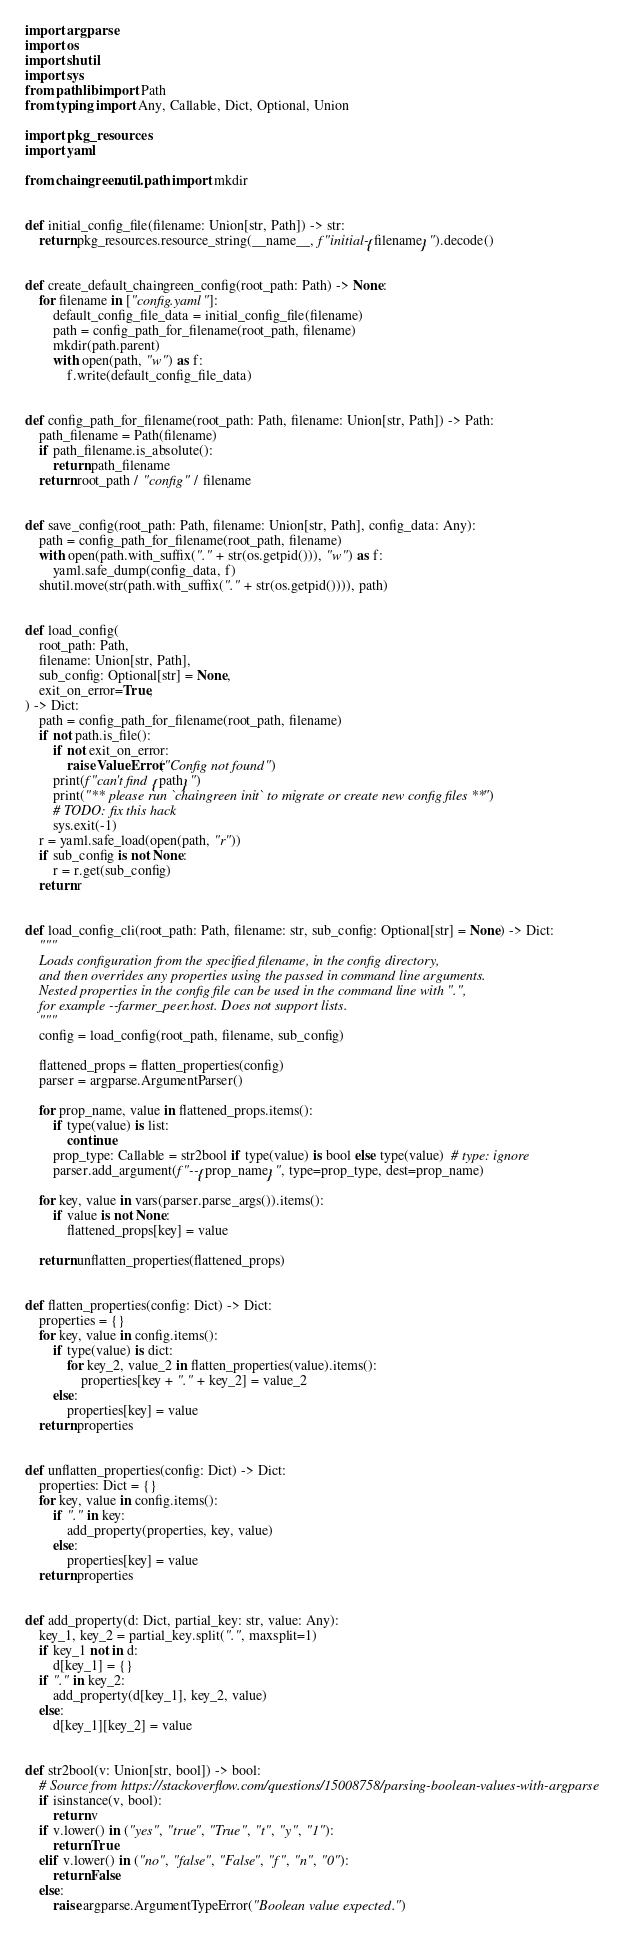Convert code to text. <code><loc_0><loc_0><loc_500><loc_500><_Python_>import argparse
import os
import shutil
import sys
from pathlib import Path
from typing import Any, Callable, Dict, Optional, Union

import pkg_resources
import yaml

from chaingreen.util.path import mkdir


def initial_config_file(filename: Union[str, Path]) -> str:
    return pkg_resources.resource_string(__name__, f"initial-{filename}").decode()


def create_default_chaingreen_config(root_path: Path) -> None:
    for filename in ["config.yaml"]:
        default_config_file_data = initial_config_file(filename)
        path = config_path_for_filename(root_path, filename)
        mkdir(path.parent)
        with open(path, "w") as f:
            f.write(default_config_file_data)


def config_path_for_filename(root_path: Path, filename: Union[str, Path]) -> Path:
    path_filename = Path(filename)
    if path_filename.is_absolute():
        return path_filename
    return root_path / "config" / filename


def save_config(root_path: Path, filename: Union[str, Path], config_data: Any):
    path = config_path_for_filename(root_path, filename)
    with open(path.with_suffix("." + str(os.getpid())), "w") as f:
        yaml.safe_dump(config_data, f)
    shutil.move(str(path.with_suffix("." + str(os.getpid()))), path)


def load_config(
    root_path: Path,
    filename: Union[str, Path],
    sub_config: Optional[str] = None,
    exit_on_error=True,
) -> Dict:
    path = config_path_for_filename(root_path, filename)
    if not path.is_file():
        if not exit_on_error:
            raise ValueError("Config not found")
        print(f"can't find {path}")
        print("** please run `chaingreen init` to migrate or create new config files **")
        # TODO: fix this hack
        sys.exit(-1)
    r = yaml.safe_load(open(path, "r"))
    if sub_config is not None:
        r = r.get(sub_config)
    return r


def load_config_cli(root_path: Path, filename: str, sub_config: Optional[str] = None) -> Dict:
    """
    Loads configuration from the specified filename, in the config directory,
    and then overrides any properties using the passed in command line arguments.
    Nested properties in the config file can be used in the command line with ".",
    for example --farmer_peer.host. Does not support lists.
    """
    config = load_config(root_path, filename, sub_config)

    flattened_props = flatten_properties(config)
    parser = argparse.ArgumentParser()

    for prop_name, value in flattened_props.items():
        if type(value) is list:
            continue
        prop_type: Callable = str2bool if type(value) is bool else type(value)  # type: ignore
        parser.add_argument(f"--{prop_name}", type=prop_type, dest=prop_name)

    for key, value in vars(parser.parse_args()).items():
        if value is not None:
            flattened_props[key] = value

    return unflatten_properties(flattened_props)


def flatten_properties(config: Dict) -> Dict:
    properties = {}
    for key, value in config.items():
        if type(value) is dict:
            for key_2, value_2 in flatten_properties(value).items():
                properties[key + "." + key_2] = value_2
        else:
            properties[key] = value
    return properties


def unflatten_properties(config: Dict) -> Dict:
    properties: Dict = {}
    for key, value in config.items():
        if "." in key:
            add_property(properties, key, value)
        else:
            properties[key] = value
    return properties


def add_property(d: Dict, partial_key: str, value: Any):
    key_1, key_2 = partial_key.split(".", maxsplit=1)
    if key_1 not in d:
        d[key_1] = {}
    if "." in key_2:
        add_property(d[key_1], key_2, value)
    else:
        d[key_1][key_2] = value


def str2bool(v: Union[str, bool]) -> bool:
    # Source from https://stackoverflow.com/questions/15008758/parsing-boolean-values-with-argparse
    if isinstance(v, bool):
        return v
    if v.lower() in ("yes", "true", "True", "t", "y", "1"):
        return True
    elif v.lower() in ("no", "false", "False", "f", "n", "0"):
        return False
    else:
        raise argparse.ArgumentTypeError("Boolean value expected.")
</code> 